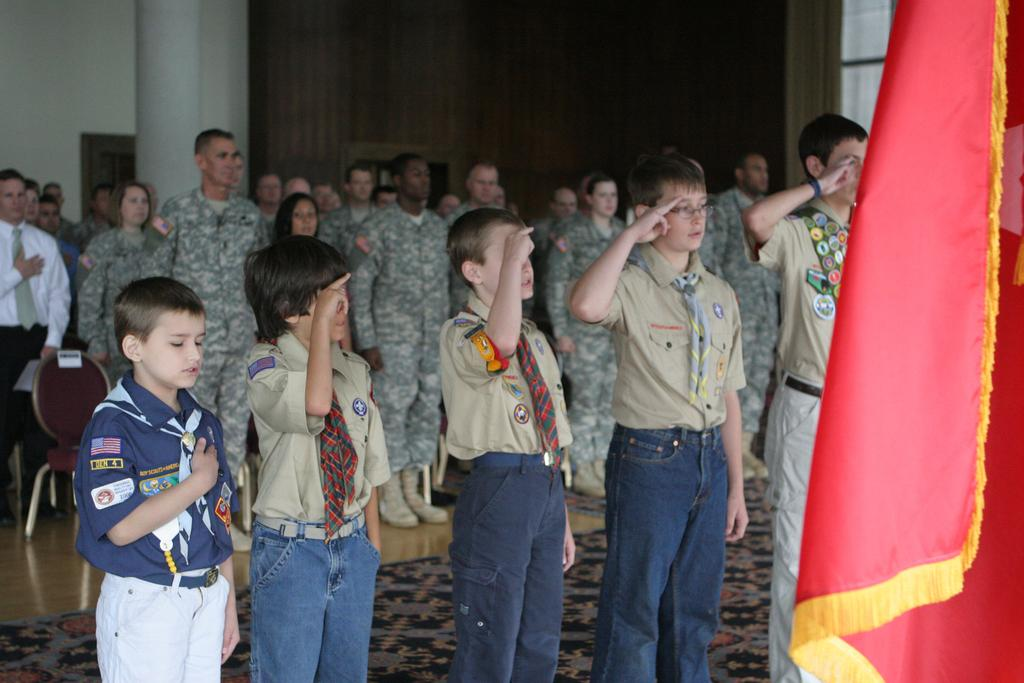What is located on the right side of the image? There is a flag on the right side of the image. What can be seen in the center of the image? There are persons standing in the center of the image. What architectural feature is visible in the background of the image? There is a pillar in the background of the image. What else can be seen in the background of the image? There are doors in the background of the image. What type of animal is delivering the news in the image? There is no animal delivering news in the image. Where is the hall located in the image? There is no hall present in the image. 